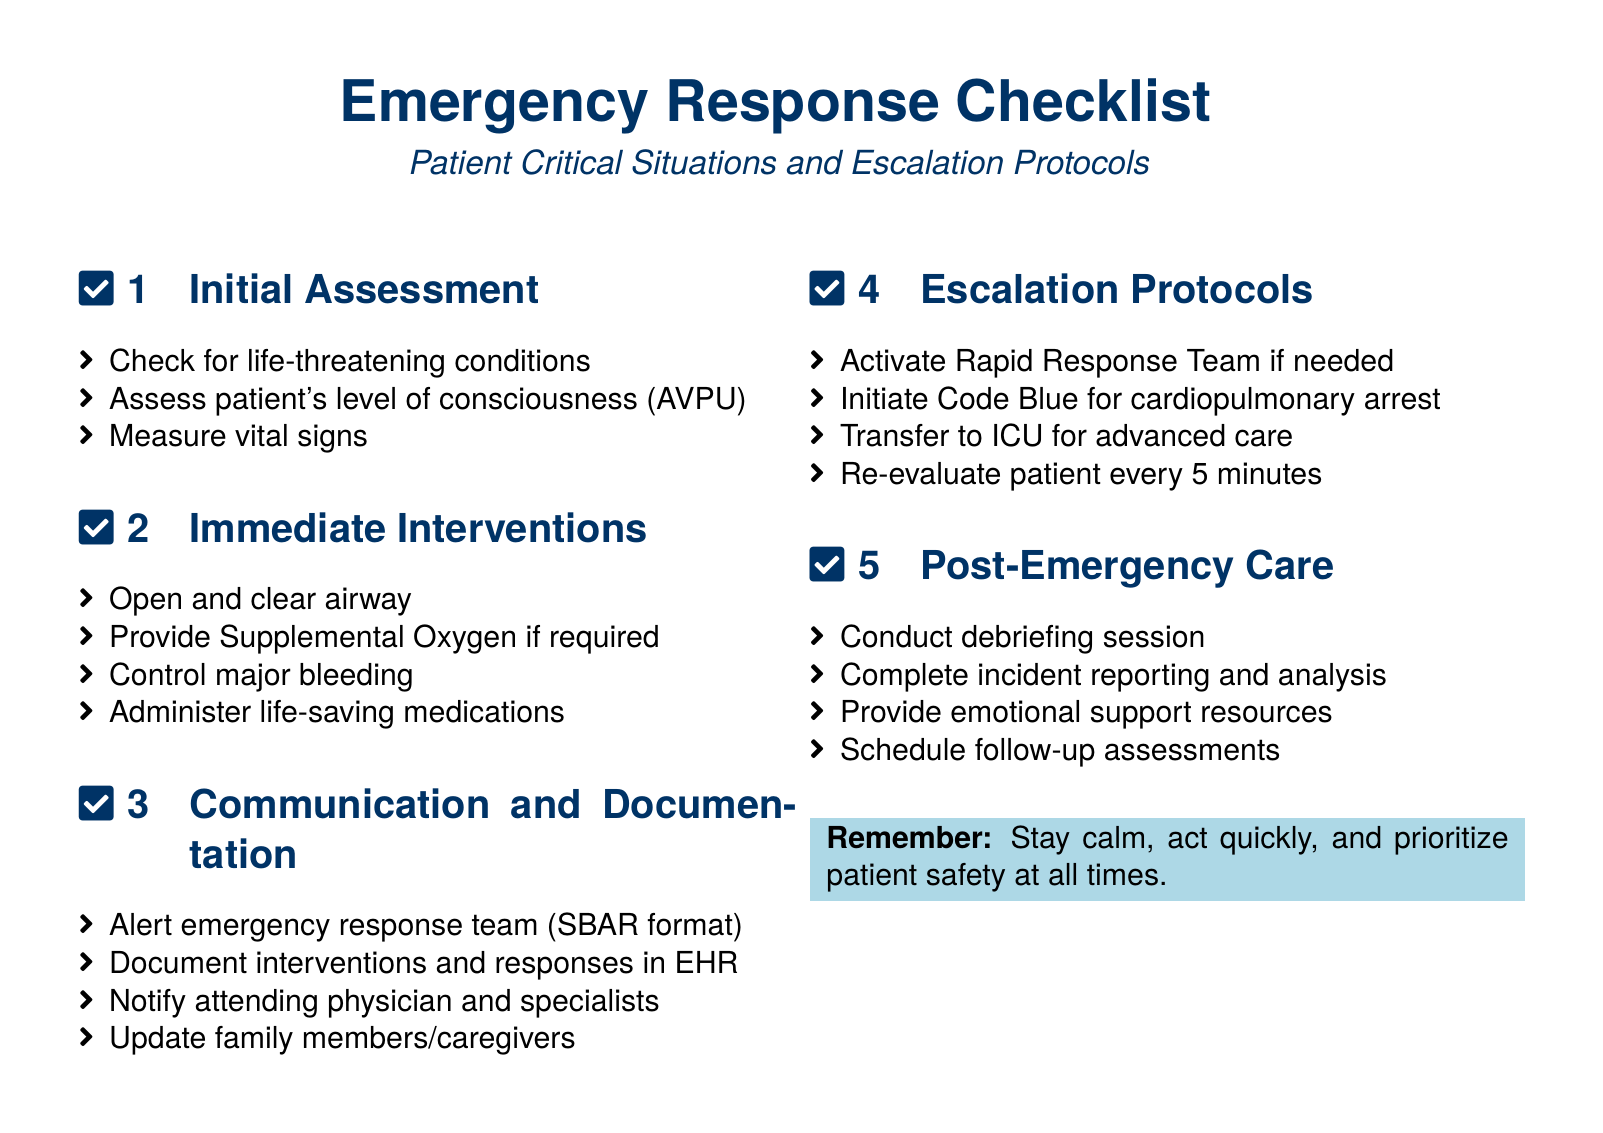What are the three areas assessed in the Initial Assessment section? The three areas assessed include life-threatening conditions, level of consciousness (AVPU), and vital signs.
Answer: life-threatening conditions, level of consciousness (AVPU), vital signs What does SBAR stand for in the Communication and Documentation section? SBAR stands for Situation, Background, Assessment, Recommendation, although the document doesn't define it explicitly.
Answer: Situation, Background, Assessment, Recommendation How often should a patient be re-evaluated according to the Escalation Protocols? The document specifies that the patient should be re-evaluated every 5 minutes.
Answer: every 5 minutes What emotional support resources should be provided in the Post-Emergency Care section? The document states that emotional support resources should be provided without specifying details.
Answer: emotional support resources What immediate intervention is required to control severe blood loss? The document lists control major bleeding as an intervention to address severe blood loss.
Answer: control major bleeding What action is to be taken if there is a cardiopulmonary arrest? The document indicates that a Code Blue should be initiated for cardiopulmonary arrest.
Answer: initiate Code Blue 